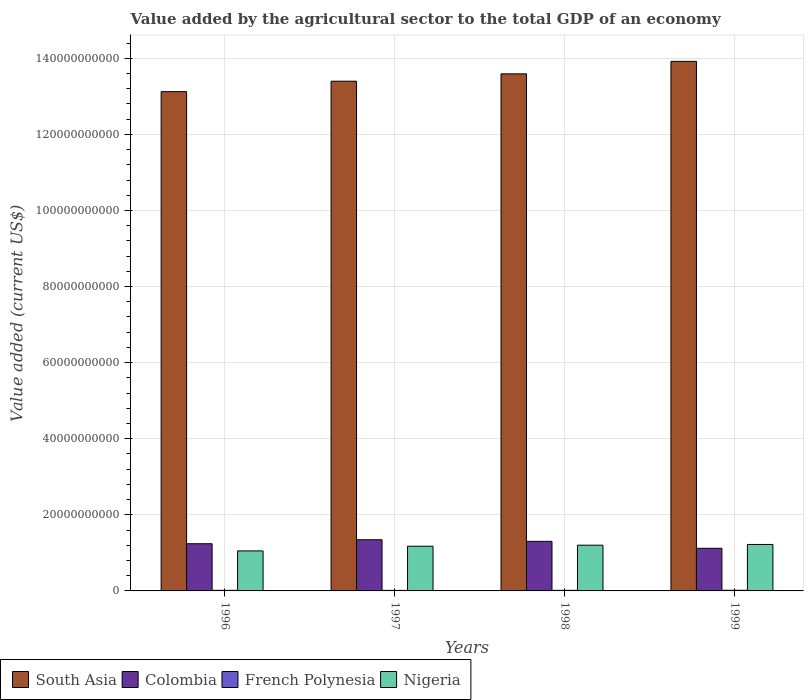Are the number of bars on each tick of the X-axis equal?
Your response must be concise. Yes. How many bars are there on the 2nd tick from the right?
Keep it short and to the point. 4. What is the value added by the agricultural sector to the total GDP in Colombia in 1997?
Offer a terse response. 1.34e+1. Across all years, what is the maximum value added by the agricultural sector to the total GDP in French Polynesia?
Offer a very short reply. 1.71e+08. Across all years, what is the minimum value added by the agricultural sector to the total GDP in Colombia?
Ensure brevity in your answer.  1.12e+1. In which year was the value added by the agricultural sector to the total GDP in French Polynesia maximum?
Your answer should be very brief. 1999. What is the total value added by the agricultural sector to the total GDP in Nigeria in the graph?
Make the answer very short. 4.65e+1. What is the difference between the value added by the agricultural sector to the total GDP in Colombia in 1996 and that in 1998?
Make the answer very short. -6.24e+08. What is the difference between the value added by the agricultural sector to the total GDP in French Polynesia in 1997 and the value added by the agricultural sector to the total GDP in Colombia in 1996?
Ensure brevity in your answer.  -1.23e+1. What is the average value added by the agricultural sector to the total GDP in French Polynesia per year?
Your answer should be very brief. 1.54e+08. In the year 1997, what is the difference between the value added by the agricultural sector to the total GDP in French Polynesia and value added by the agricultural sector to the total GDP in Nigeria?
Offer a very short reply. -1.16e+1. In how many years, is the value added by the agricultural sector to the total GDP in French Polynesia greater than 128000000000 US$?
Ensure brevity in your answer.  0. What is the ratio of the value added by the agricultural sector to the total GDP in Colombia in 1998 to that in 1999?
Make the answer very short. 1.16. Is the value added by the agricultural sector to the total GDP in Colombia in 1996 less than that in 1999?
Make the answer very short. No. Is the difference between the value added by the agricultural sector to the total GDP in French Polynesia in 1996 and 1999 greater than the difference between the value added by the agricultural sector to the total GDP in Nigeria in 1996 and 1999?
Provide a succinct answer. Yes. What is the difference between the highest and the second highest value added by the agricultural sector to the total GDP in South Asia?
Your answer should be very brief. 3.28e+09. What is the difference between the highest and the lowest value added by the agricultural sector to the total GDP in French Polynesia?
Provide a succinct answer. 3.25e+07. What does the 4th bar from the left in 1996 represents?
Offer a terse response. Nigeria. Is it the case that in every year, the sum of the value added by the agricultural sector to the total GDP in Colombia and value added by the agricultural sector to the total GDP in French Polynesia is greater than the value added by the agricultural sector to the total GDP in Nigeria?
Your response must be concise. No. How many years are there in the graph?
Offer a terse response. 4. Does the graph contain any zero values?
Your response must be concise. No. Where does the legend appear in the graph?
Your answer should be very brief. Bottom left. How are the legend labels stacked?
Keep it short and to the point. Horizontal. What is the title of the graph?
Provide a short and direct response. Value added by the agricultural sector to the total GDP of an economy. What is the label or title of the Y-axis?
Provide a succinct answer. Value added (current US$). What is the Value added (current US$) of South Asia in 1996?
Provide a short and direct response. 1.31e+11. What is the Value added (current US$) in Colombia in 1996?
Your answer should be very brief. 1.24e+1. What is the Value added (current US$) of French Polynesia in 1996?
Offer a very short reply. 1.55e+08. What is the Value added (current US$) of Nigeria in 1996?
Ensure brevity in your answer.  1.05e+1. What is the Value added (current US$) of South Asia in 1997?
Ensure brevity in your answer.  1.34e+11. What is the Value added (current US$) in Colombia in 1997?
Offer a very short reply. 1.34e+1. What is the Value added (current US$) of French Polynesia in 1997?
Give a very brief answer. 1.38e+08. What is the Value added (current US$) of Nigeria in 1997?
Your response must be concise. 1.18e+1. What is the Value added (current US$) of South Asia in 1998?
Provide a succinct answer. 1.36e+11. What is the Value added (current US$) in Colombia in 1998?
Offer a terse response. 1.30e+1. What is the Value added (current US$) of French Polynesia in 1998?
Give a very brief answer. 1.53e+08. What is the Value added (current US$) of Nigeria in 1998?
Provide a succinct answer. 1.20e+1. What is the Value added (current US$) of South Asia in 1999?
Make the answer very short. 1.39e+11. What is the Value added (current US$) of Colombia in 1999?
Keep it short and to the point. 1.12e+1. What is the Value added (current US$) in French Polynesia in 1999?
Keep it short and to the point. 1.71e+08. What is the Value added (current US$) in Nigeria in 1999?
Give a very brief answer. 1.22e+1. Across all years, what is the maximum Value added (current US$) in South Asia?
Offer a very short reply. 1.39e+11. Across all years, what is the maximum Value added (current US$) in Colombia?
Provide a short and direct response. 1.34e+1. Across all years, what is the maximum Value added (current US$) of French Polynesia?
Offer a terse response. 1.71e+08. Across all years, what is the maximum Value added (current US$) of Nigeria?
Your answer should be compact. 1.22e+1. Across all years, what is the minimum Value added (current US$) in South Asia?
Your answer should be very brief. 1.31e+11. Across all years, what is the minimum Value added (current US$) of Colombia?
Provide a succinct answer. 1.12e+1. Across all years, what is the minimum Value added (current US$) in French Polynesia?
Your answer should be compact. 1.38e+08. Across all years, what is the minimum Value added (current US$) of Nigeria?
Make the answer very short. 1.05e+1. What is the total Value added (current US$) in South Asia in the graph?
Give a very brief answer. 5.40e+11. What is the total Value added (current US$) in Colombia in the graph?
Give a very brief answer. 5.01e+1. What is the total Value added (current US$) of French Polynesia in the graph?
Your answer should be compact. 6.17e+08. What is the total Value added (current US$) in Nigeria in the graph?
Keep it short and to the point. 4.65e+1. What is the difference between the Value added (current US$) of South Asia in 1996 and that in 1997?
Provide a short and direct response. -2.74e+09. What is the difference between the Value added (current US$) of Colombia in 1996 and that in 1997?
Offer a very short reply. -1.04e+09. What is the difference between the Value added (current US$) of French Polynesia in 1996 and that in 1997?
Your response must be concise. 1.73e+07. What is the difference between the Value added (current US$) of Nigeria in 1996 and that in 1997?
Give a very brief answer. -1.23e+09. What is the difference between the Value added (current US$) in South Asia in 1996 and that in 1998?
Provide a succinct answer. -4.67e+09. What is the difference between the Value added (current US$) in Colombia in 1996 and that in 1998?
Your response must be concise. -6.24e+08. What is the difference between the Value added (current US$) of French Polynesia in 1996 and that in 1998?
Provide a short and direct response. 2.21e+06. What is the difference between the Value added (current US$) of Nigeria in 1996 and that in 1998?
Offer a terse response. -1.50e+09. What is the difference between the Value added (current US$) of South Asia in 1996 and that in 1999?
Provide a short and direct response. -7.96e+09. What is the difference between the Value added (current US$) in Colombia in 1996 and that in 1999?
Offer a terse response. 1.20e+09. What is the difference between the Value added (current US$) of French Polynesia in 1996 and that in 1999?
Offer a very short reply. -1.52e+07. What is the difference between the Value added (current US$) in Nigeria in 1996 and that in 1999?
Ensure brevity in your answer.  -1.69e+09. What is the difference between the Value added (current US$) in South Asia in 1997 and that in 1998?
Make the answer very short. -1.94e+09. What is the difference between the Value added (current US$) of Colombia in 1997 and that in 1998?
Ensure brevity in your answer.  4.16e+08. What is the difference between the Value added (current US$) of French Polynesia in 1997 and that in 1998?
Ensure brevity in your answer.  -1.50e+07. What is the difference between the Value added (current US$) of Nigeria in 1997 and that in 1998?
Your answer should be very brief. -2.66e+08. What is the difference between the Value added (current US$) of South Asia in 1997 and that in 1999?
Provide a succinct answer. -5.22e+09. What is the difference between the Value added (current US$) in Colombia in 1997 and that in 1999?
Provide a short and direct response. 2.24e+09. What is the difference between the Value added (current US$) in French Polynesia in 1997 and that in 1999?
Give a very brief answer. -3.25e+07. What is the difference between the Value added (current US$) of Nigeria in 1997 and that in 1999?
Provide a short and direct response. -4.61e+08. What is the difference between the Value added (current US$) of South Asia in 1998 and that in 1999?
Your answer should be very brief. -3.28e+09. What is the difference between the Value added (current US$) of Colombia in 1998 and that in 1999?
Your answer should be compact. 1.82e+09. What is the difference between the Value added (current US$) of French Polynesia in 1998 and that in 1999?
Provide a short and direct response. -1.75e+07. What is the difference between the Value added (current US$) in Nigeria in 1998 and that in 1999?
Your answer should be very brief. -1.95e+08. What is the difference between the Value added (current US$) in South Asia in 1996 and the Value added (current US$) in Colombia in 1997?
Make the answer very short. 1.18e+11. What is the difference between the Value added (current US$) in South Asia in 1996 and the Value added (current US$) in French Polynesia in 1997?
Give a very brief answer. 1.31e+11. What is the difference between the Value added (current US$) in South Asia in 1996 and the Value added (current US$) in Nigeria in 1997?
Keep it short and to the point. 1.19e+11. What is the difference between the Value added (current US$) in Colombia in 1996 and the Value added (current US$) in French Polynesia in 1997?
Offer a terse response. 1.23e+1. What is the difference between the Value added (current US$) in Colombia in 1996 and the Value added (current US$) in Nigeria in 1997?
Your answer should be very brief. 6.54e+08. What is the difference between the Value added (current US$) of French Polynesia in 1996 and the Value added (current US$) of Nigeria in 1997?
Your answer should be compact. -1.16e+1. What is the difference between the Value added (current US$) of South Asia in 1996 and the Value added (current US$) of Colombia in 1998?
Provide a short and direct response. 1.18e+11. What is the difference between the Value added (current US$) in South Asia in 1996 and the Value added (current US$) in French Polynesia in 1998?
Your answer should be very brief. 1.31e+11. What is the difference between the Value added (current US$) of South Asia in 1996 and the Value added (current US$) of Nigeria in 1998?
Make the answer very short. 1.19e+11. What is the difference between the Value added (current US$) in Colombia in 1996 and the Value added (current US$) in French Polynesia in 1998?
Make the answer very short. 1.23e+1. What is the difference between the Value added (current US$) of Colombia in 1996 and the Value added (current US$) of Nigeria in 1998?
Make the answer very short. 3.88e+08. What is the difference between the Value added (current US$) in French Polynesia in 1996 and the Value added (current US$) in Nigeria in 1998?
Offer a very short reply. -1.19e+1. What is the difference between the Value added (current US$) of South Asia in 1996 and the Value added (current US$) of Colombia in 1999?
Provide a short and direct response. 1.20e+11. What is the difference between the Value added (current US$) of South Asia in 1996 and the Value added (current US$) of French Polynesia in 1999?
Your response must be concise. 1.31e+11. What is the difference between the Value added (current US$) of South Asia in 1996 and the Value added (current US$) of Nigeria in 1999?
Make the answer very short. 1.19e+11. What is the difference between the Value added (current US$) in Colombia in 1996 and the Value added (current US$) in French Polynesia in 1999?
Give a very brief answer. 1.22e+1. What is the difference between the Value added (current US$) in Colombia in 1996 and the Value added (current US$) in Nigeria in 1999?
Provide a short and direct response. 1.94e+08. What is the difference between the Value added (current US$) in French Polynesia in 1996 and the Value added (current US$) in Nigeria in 1999?
Make the answer very short. -1.21e+1. What is the difference between the Value added (current US$) of South Asia in 1997 and the Value added (current US$) of Colombia in 1998?
Your answer should be very brief. 1.21e+11. What is the difference between the Value added (current US$) in South Asia in 1997 and the Value added (current US$) in French Polynesia in 1998?
Keep it short and to the point. 1.34e+11. What is the difference between the Value added (current US$) in South Asia in 1997 and the Value added (current US$) in Nigeria in 1998?
Your answer should be compact. 1.22e+11. What is the difference between the Value added (current US$) in Colombia in 1997 and the Value added (current US$) in French Polynesia in 1998?
Provide a succinct answer. 1.33e+1. What is the difference between the Value added (current US$) in Colombia in 1997 and the Value added (current US$) in Nigeria in 1998?
Offer a terse response. 1.43e+09. What is the difference between the Value added (current US$) of French Polynesia in 1997 and the Value added (current US$) of Nigeria in 1998?
Offer a terse response. -1.19e+1. What is the difference between the Value added (current US$) in South Asia in 1997 and the Value added (current US$) in Colombia in 1999?
Your answer should be compact. 1.23e+11. What is the difference between the Value added (current US$) in South Asia in 1997 and the Value added (current US$) in French Polynesia in 1999?
Your response must be concise. 1.34e+11. What is the difference between the Value added (current US$) in South Asia in 1997 and the Value added (current US$) in Nigeria in 1999?
Offer a very short reply. 1.22e+11. What is the difference between the Value added (current US$) of Colombia in 1997 and the Value added (current US$) of French Polynesia in 1999?
Ensure brevity in your answer.  1.33e+1. What is the difference between the Value added (current US$) in Colombia in 1997 and the Value added (current US$) in Nigeria in 1999?
Give a very brief answer. 1.23e+09. What is the difference between the Value added (current US$) of French Polynesia in 1997 and the Value added (current US$) of Nigeria in 1999?
Give a very brief answer. -1.21e+1. What is the difference between the Value added (current US$) in South Asia in 1998 and the Value added (current US$) in Colombia in 1999?
Provide a short and direct response. 1.25e+11. What is the difference between the Value added (current US$) in South Asia in 1998 and the Value added (current US$) in French Polynesia in 1999?
Your response must be concise. 1.36e+11. What is the difference between the Value added (current US$) in South Asia in 1998 and the Value added (current US$) in Nigeria in 1999?
Provide a succinct answer. 1.24e+11. What is the difference between the Value added (current US$) of Colombia in 1998 and the Value added (current US$) of French Polynesia in 1999?
Provide a succinct answer. 1.29e+1. What is the difference between the Value added (current US$) of Colombia in 1998 and the Value added (current US$) of Nigeria in 1999?
Offer a very short reply. 8.17e+08. What is the difference between the Value added (current US$) of French Polynesia in 1998 and the Value added (current US$) of Nigeria in 1999?
Give a very brief answer. -1.21e+1. What is the average Value added (current US$) of South Asia per year?
Offer a very short reply. 1.35e+11. What is the average Value added (current US$) in Colombia per year?
Keep it short and to the point. 1.25e+1. What is the average Value added (current US$) in French Polynesia per year?
Give a very brief answer. 1.54e+08. What is the average Value added (current US$) of Nigeria per year?
Keep it short and to the point. 1.16e+1. In the year 1996, what is the difference between the Value added (current US$) of South Asia and Value added (current US$) of Colombia?
Your answer should be compact. 1.19e+11. In the year 1996, what is the difference between the Value added (current US$) of South Asia and Value added (current US$) of French Polynesia?
Offer a very short reply. 1.31e+11. In the year 1996, what is the difference between the Value added (current US$) in South Asia and Value added (current US$) in Nigeria?
Your answer should be compact. 1.21e+11. In the year 1996, what is the difference between the Value added (current US$) of Colombia and Value added (current US$) of French Polynesia?
Your answer should be compact. 1.23e+1. In the year 1996, what is the difference between the Value added (current US$) of Colombia and Value added (current US$) of Nigeria?
Provide a succinct answer. 1.89e+09. In the year 1996, what is the difference between the Value added (current US$) of French Polynesia and Value added (current US$) of Nigeria?
Your answer should be very brief. -1.04e+1. In the year 1997, what is the difference between the Value added (current US$) of South Asia and Value added (current US$) of Colombia?
Your answer should be very brief. 1.21e+11. In the year 1997, what is the difference between the Value added (current US$) in South Asia and Value added (current US$) in French Polynesia?
Provide a succinct answer. 1.34e+11. In the year 1997, what is the difference between the Value added (current US$) of South Asia and Value added (current US$) of Nigeria?
Your answer should be compact. 1.22e+11. In the year 1997, what is the difference between the Value added (current US$) of Colombia and Value added (current US$) of French Polynesia?
Offer a terse response. 1.33e+1. In the year 1997, what is the difference between the Value added (current US$) in Colombia and Value added (current US$) in Nigeria?
Offer a terse response. 1.69e+09. In the year 1997, what is the difference between the Value added (current US$) in French Polynesia and Value added (current US$) in Nigeria?
Offer a terse response. -1.16e+1. In the year 1998, what is the difference between the Value added (current US$) of South Asia and Value added (current US$) of Colombia?
Provide a short and direct response. 1.23e+11. In the year 1998, what is the difference between the Value added (current US$) in South Asia and Value added (current US$) in French Polynesia?
Your answer should be very brief. 1.36e+11. In the year 1998, what is the difference between the Value added (current US$) of South Asia and Value added (current US$) of Nigeria?
Ensure brevity in your answer.  1.24e+11. In the year 1998, what is the difference between the Value added (current US$) in Colombia and Value added (current US$) in French Polynesia?
Provide a succinct answer. 1.29e+1. In the year 1998, what is the difference between the Value added (current US$) of Colombia and Value added (current US$) of Nigeria?
Offer a terse response. 1.01e+09. In the year 1998, what is the difference between the Value added (current US$) in French Polynesia and Value added (current US$) in Nigeria?
Offer a terse response. -1.19e+1. In the year 1999, what is the difference between the Value added (current US$) of South Asia and Value added (current US$) of Colombia?
Your response must be concise. 1.28e+11. In the year 1999, what is the difference between the Value added (current US$) in South Asia and Value added (current US$) in French Polynesia?
Offer a very short reply. 1.39e+11. In the year 1999, what is the difference between the Value added (current US$) in South Asia and Value added (current US$) in Nigeria?
Provide a short and direct response. 1.27e+11. In the year 1999, what is the difference between the Value added (current US$) of Colombia and Value added (current US$) of French Polynesia?
Make the answer very short. 1.10e+1. In the year 1999, what is the difference between the Value added (current US$) of Colombia and Value added (current US$) of Nigeria?
Your answer should be compact. -1.01e+09. In the year 1999, what is the difference between the Value added (current US$) in French Polynesia and Value added (current US$) in Nigeria?
Keep it short and to the point. -1.20e+1. What is the ratio of the Value added (current US$) in South Asia in 1996 to that in 1997?
Your answer should be compact. 0.98. What is the ratio of the Value added (current US$) in Colombia in 1996 to that in 1997?
Provide a succinct answer. 0.92. What is the ratio of the Value added (current US$) of French Polynesia in 1996 to that in 1997?
Keep it short and to the point. 1.12. What is the ratio of the Value added (current US$) of Nigeria in 1996 to that in 1997?
Offer a terse response. 0.9. What is the ratio of the Value added (current US$) of South Asia in 1996 to that in 1998?
Your answer should be very brief. 0.97. What is the ratio of the Value added (current US$) of Colombia in 1996 to that in 1998?
Provide a short and direct response. 0.95. What is the ratio of the Value added (current US$) in French Polynesia in 1996 to that in 1998?
Keep it short and to the point. 1.01. What is the ratio of the Value added (current US$) of Nigeria in 1996 to that in 1998?
Offer a terse response. 0.88. What is the ratio of the Value added (current US$) in South Asia in 1996 to that in 1999?
Offer a very short reply. 0.94. What is the ratio of the Value added (current US$) of Colombia in 1996 to that in 1999?
Give a very brief answer. 1.11. What is the ratio of the Value added (current US$) of French Polynesia in 1996 to that in 1999?
Keep it short and to the point. 0.91. What is the ratio of the Value added (current US$) of Nigeria in 1996 to that in 1999?
Your answer should be compact. 0.86. What is the ratio of the Value added (current US$) of South Asia in 1997 to that in 1998?
Offer a very short reply. 0.99. What is the ratio of the Value added (current US$) in Colombia in 1997 to that in 1998?
Provide a short and direct response. 1.03. What is the ratio of the Value added (current US$) of French Polynesia in 1997 to that in 1998?
Your answer should be compact. 0.9. What is the ratio of the Value added (current US$) in Nigeria in 1997 to that in 1998?
Provide a short and direct response. 0.98. What is the ratio of the Value added (current US$) of South Asia in 1997 to that in 1999?
Your response must be concise. 0.96. What is the ratio of the Value added (current US$) of French Polynesia in 1997 to that in 1999?
Your answer should be very brief. 0.81. What is the ratio of the Value added (current US$) in Nigeria in 1997 to that in 1999?
Provide a succinct answer. 0.96. What is the ratio of the Value added (current US$) in South Asia in 1998 to that in 1999?
Your answer should be very brief. 0.98. What is the ratio of the Value added (current US$) in Colombia in 1998 to that in 1999?
Your response must be concise. 1.16. What is the ratio of the Value added (current US$) in French Polynesia in 1998 to that in 1999?
Provide a succinct answer. 0.9. What is the ratio of the Value added (current US$) in Nigeria in 1998 to that in 1999?
Ensure brevity in your answer.  0.98. What is the difference between the highest and the second highest Value added (current US$) in South Asia?
Keep it short and to the point. 3.28e+09. What is the difference between the highest and the second highest Value added (current US$) of Colombia?
Give a very brief answer. 4.16e+08. What is the difference between the highest and the second highest Value added (current US$) of French Polynesia?
Provide a succinct answer. 1.52e+07. What is the difference between the highest and the second highest Value added (current US$) in Nigeria?
Your answer should be very brief. 1.95e+08. What is the difference between the highest and the lowest Value added (current US$) of South Asia?
Your answer should be very brief. 7.96e+09. What is the difference between the highest and the lowest Value added (current US$) of Colombia?
Your answer should be very brief. 2.24e+09. What is the difference between the highest and the lowest Value added (current US$) in French Polynesia?
Your answer should be compact. 3.25e+07. What is the difference between the highest and the lowest Value added (current US$) in Nigeria?
Your answer should be very brief. 1.69e+09. 